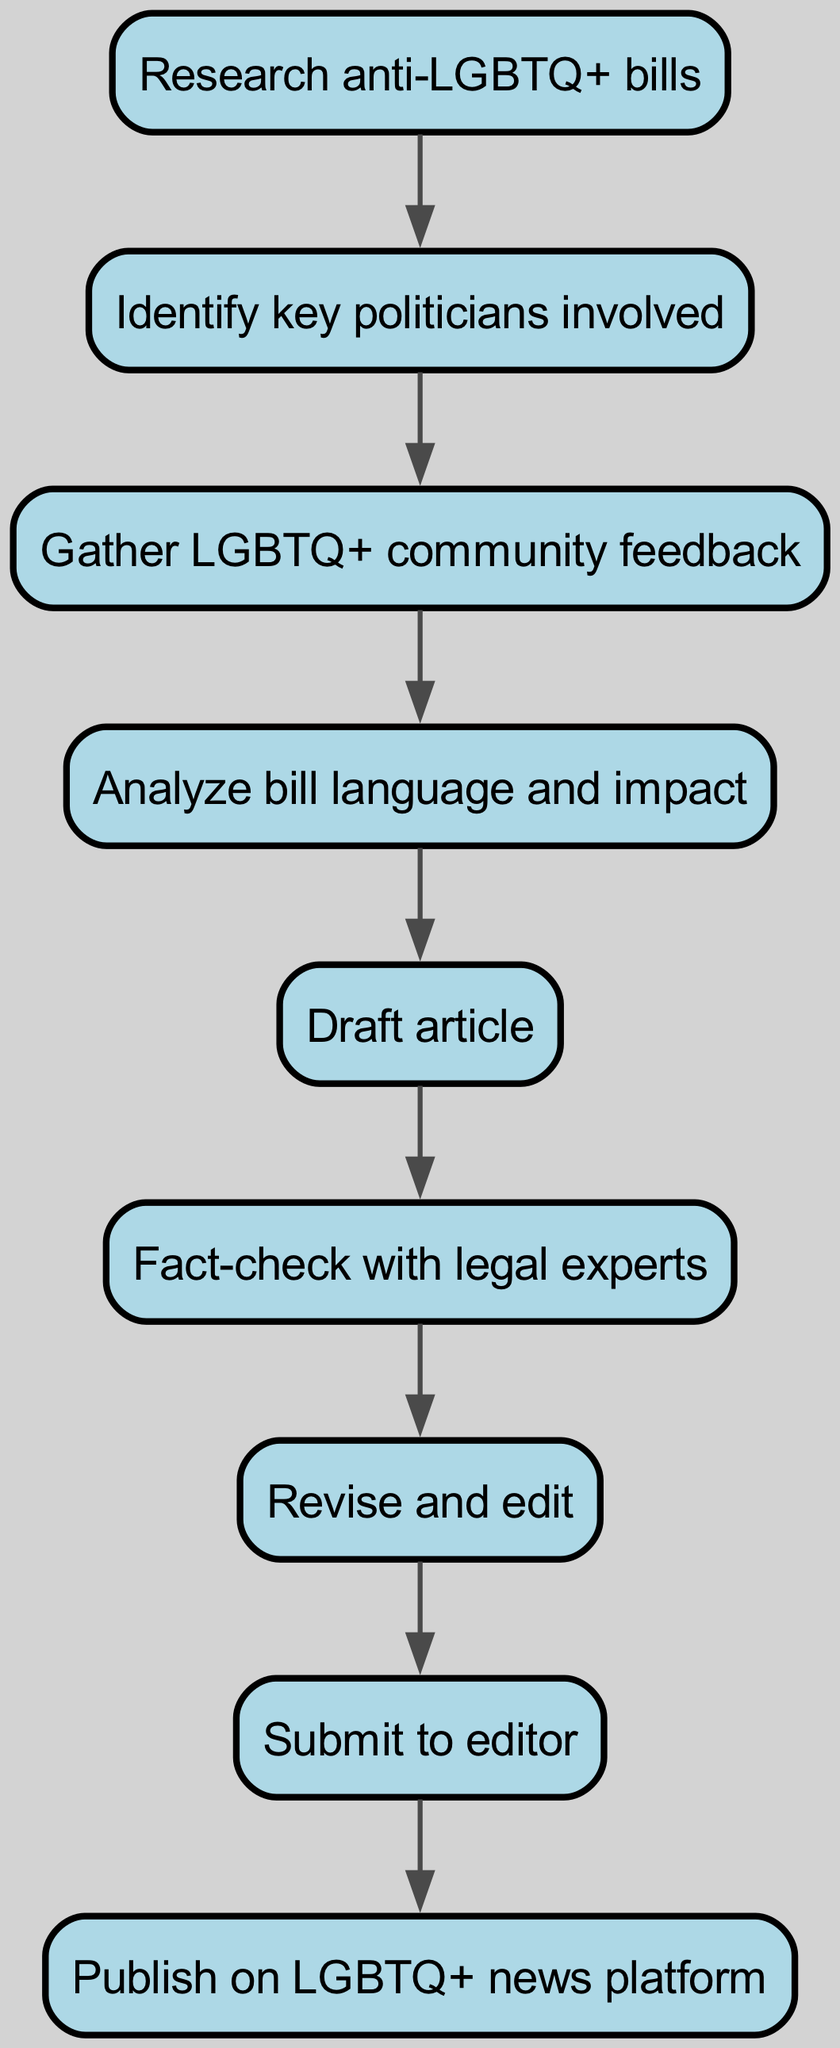What is the first step in the process? The first node in the flowchart is labeled "Research anti-LGBTQ+ bills," indicating that this is the starting point of the process for creating the investigative article.
Answer: Research anti-LGBTQ+ bills How many nodes are present in the diagram? By counting the distinct nodes listed in the data, there are nine unique steps, each representing a different part of the article's content creation process.
Answer: 9 What is the last step before publication? The final step before publishing the article is submitted to the editor, which is represented by the node labeled "Submit to editor."
Answer: Submit to editor Which step follows after gathering community feedback? The flowchart shows that after "Gather LGBTQ+ community feedback," the next step is to "Analyze bill language and impact." This direct connection indicates the sequence of tasks.
Answer: Analyze bill language and impact What two steps are directly connected before drafting the article? Before drafting the article, two steps are completed: "Analyze bill language and impact" feeds directly into "Draft article." This shows the flow of information leading to the creation of the draft.
Answer: Analyze bill language and impact, Draft article How many edges connect the nodes in the diagram? Each edge represents a direct relationship or flow from one step to the next. There are eight connections in total, indicating the sequence of the content creation process.
Answer: 8 What is the relationship between identifying politicians and gathering community feedback? The diagram indicates that "Identify key politicians involved" leads directly to "Gather LGBTQ+ community feedback," showing that the information about politicians is necessary to solicit relevant feedback from the community.
Answer: Identify key politicians involved, Gather LGBTQ+ community feedback What verifies the information before revising the article? The "Fact-check with legal experts" step must be completed before moving on to "Revise and edit," ensuring that the facts stated in the article are accurate and credible before it is polished further.
Answer: Fact-check with legal experts 